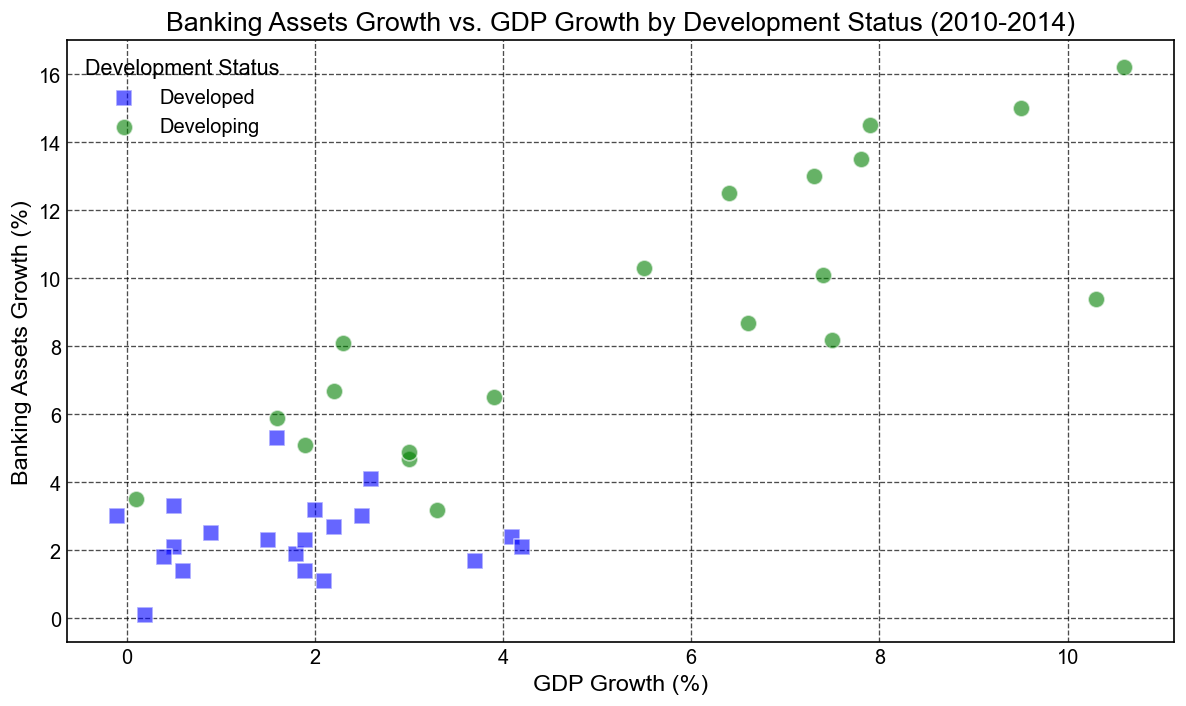Which country shows the highest Banking Assets Growth (%) in the plot? By examining the dots, China has the highest Banking Assets Growth (%) which is represented by a green dot with the highest vertical position. Specifically, the dot indicating China in 2010 has a value of 16.2%.
Answer: China (2010) Which development status group shows generally higher Banking Assets Growth (%)? By inspecting the colors of the dots, the green dots (developing countries) are generally located higher in the plot indicating higher Banking Assets Growth (%) compared to the blue dots (developed countries).
Answer: Developing Which country had the highest GDP Growth (%) in the dataset and what was the corresponding Banking Assets Growth (%)? By looking for the data point with the highest horizontal position, India had the highest GDP Growth (%) of 10.3% in 2010, and the corresponding Banking Assets Growth (%) was 9.4%.
Answer: India (10.3% GDP, 9.4% Banking Assets) How does the Banking Assets Growth (%) of the United States compare to that of South Africa in 2014? Locate the green dot (South Africa) and blue dot (United States) for the year 2014, then compare the vertical positions. South Africa has a Banking Assets Growth of 5.9%, compared to the United States' 3.0%.
Answer: South Africa (5.9%) > United States (3.0%) What is the average GDP Growth (%) for developing countries shown in the scatter plot? Identify the GDP Growth (%) values for Brazil, India, South Africa, and China, sum them, and then divide by the number of data points. The values are 7.5, 3.9, 1.9, 3.0, 0.1, 10.3, 6.6, 5.5, 6.4, 7.4, 3.0, 3.3, 2.2, 2.3, 1.6, 10.6, 9.5, 7.9, 7.8, 7.3. The sum is 110.5 and there are 20 data points. The average is 110.5/20 = 5.525%.
Answer: 5.525% What is the difference in GDP Growth (%) between Germany and Brazil in 2012? Locate the GDP Growth (%) for Germany in 2012 (0.5%) and for Brazil in 2012 (1.9%), then compute the difference: 1.9% - 0.5% = 1.4%.
Answer: 1.4% How does the Banking Assets Growth of Germany in 2013 compare to that of Japan in 2013? Locate the 2013 data points for Germany (3.3%) and Japan (3.2%) and compare their values. Germany's Banking Assets Growth is slightly higher.
Answer: Germany (3.3%) > Japan (3.2%) What is the trend in Banking Assets Growth (%) for China from 2010 to 2014? Analyze the vertical positions of the dots for China across the years 2010 to 2014. The values are 16.2%, 15.0%, 14.5%, 13.5%, and 13.0%, showing a gradual decrease.
Answer: Decreasing Which year shows the highest variation in GDP Growth (%) among all countries? By comparing the horizontal positions of the dots across all years, 2010 shows the highest variation with India's 10.3% on the high end and Japan's 1.9% on the low end, indicating the largest spread.
Answer: 2010 